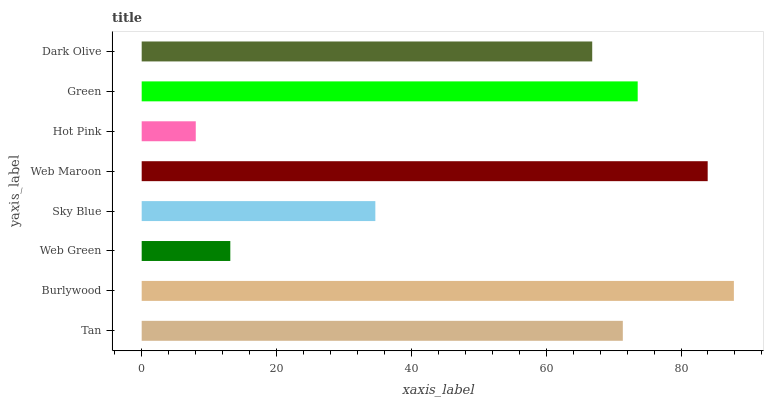Is Hot Pink the minimum?
Answer yes or no. Yes. Is Burlywood the maximum?
Answer yes or no. Yes. Is Web Green the minimum?
Answer yes or no. No. Is Web Green the maximum?
Answer yes or no. No. Is Burlywood greater than Web Green?
Answer yes or no. Yes. Is Web Green less than Burlywood?
Answer yes or no. Yes. Is Web Green greater than Burlywood?
Answer yes or no. No. Is Burlywood less than Web Green?
Answer yes or no. No. Is Tan the high median?
Answer yes or no. Yes. Is Dark Olive the low median?
Answer yes or no. Yes. Is Sky Blue the high median?
Answer yes or no. No. Is Sky Blue the low median?
Answer yes or no. No. 